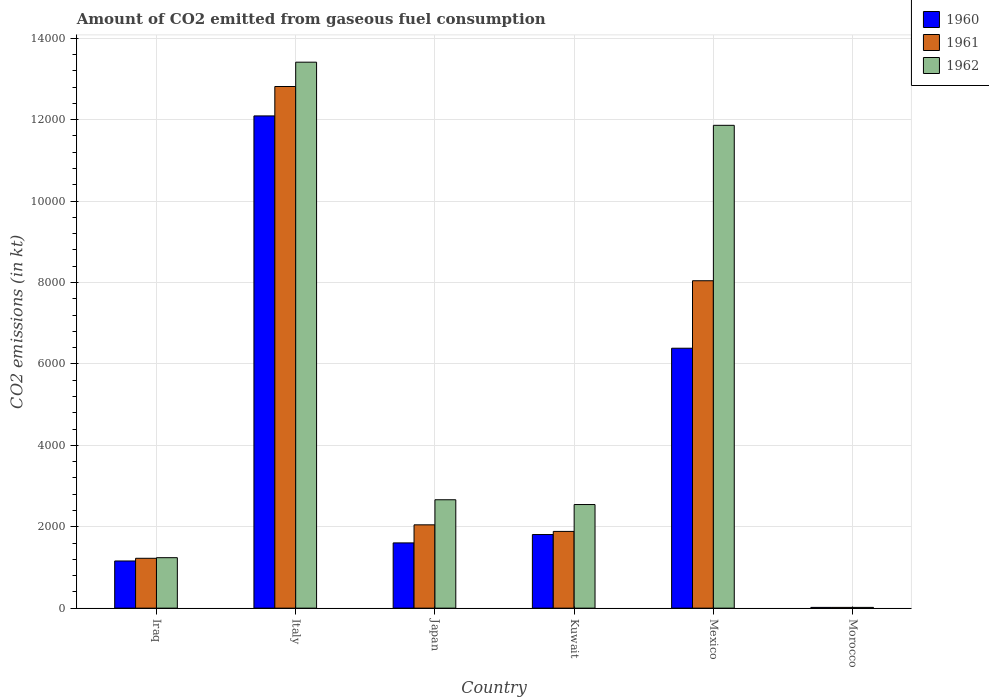How many different coloured bars are there?
Your answer should be very brief. 3. Are the number of bars on each tick of the X-axis equal?
Keep it short and to the point. Yes. How many bars are there on the 1st tick from the left?
Make the answer very short. 3. In how many cases, is the number of bars for a given country not equal to the number of legend labels?
Provide a short and direct response. 0. What is the amount of CO2 emitted in 1962 in Mexico?
Provide a short and direct response. 1.19e+04. Across all countries, what is the maximum amount of CO2 emitted in 1962?
Provide a short and direct response. 1.34e+04. Across all countries, what is the minimum amount of CO2 emitted in 1962?
Offer a terse response. 18.34. In which country was the amount of CO2 emitted in 1961 minimum?
Keep it short and to the point. Morocco. What is the total amount of CO2 emitted in 1962 in the graph?
Offer a very short reply. 3.17e+04. What is the difference between the amount of CO2 emitted in 1960 in Iraq and that in Morocco?
Ensure brevity in your answer.  1140.44. What is the difference between the amount of CO2 emitted in 1962 in Kuwait and the amount of CO2 emitted in 1960 in Morocco?
Provide a short and direct response. 2526.56. What is the average amount of CO2 emitted in 1960 per country?
Your answer should be very brief. 3843.63. What is the difference between the amount of CO2 emitted of/in 1960 and amount of CO2 emitted of/in 1961 in Iraq?
Your answer should be compact. -66.01. In how many countries, is the amount of CO2 emitted in 1961 greater than 7600 kt?
Give a very brief answer. 2. What is the ratio of the amount of CO2 emitted in 1962 in Iraq to that in Italy?
Provide a succinct answer. 0.09. Is the difference between the amount of CO2 emitted in 1960 in Iraq and Japan greater than the difference between the amount of CO2 emitted in 1961 in Iraq and Japan?
Ensure brevity in your answer.  Yes. What is the difference between the highest and the second highest amount of CO2 emitted in 1960?
Your answer should be very brief. -5705.85. What is the difference between the highest and the lowest amount of CO2 emitted in 1960?
Give a very brief answer. 1.21e+04. What does the 2nd bar from the left in Iraq represents?
Your answer should be compact. 1961. Does the graph contain any zero values?
Your answer should be compact. No. Does the graph contain grids?
Offer a terse response. Yes. Where does the legend appear in the graph?
Offer a terse response. Top right. How many legend labels are there?
Offer a very short reply. 3. How are the legend labels stacked?
Provide a short and direct response. Vertical. What is the title of the graph?
Provide a succinct answer. Amount of CO2 emitted from gaseous fuel consumption. What is the label or title of the X-axis?
Provide a short and direct response. Country. What is the label or title of the Y-axis?
Give a very brief answer. CO2 emissions (in kt). What is the CO2 emissions (in kt) in 1960 in Iraq?
Your answer should be very brief. 1158.77. What is the CO2 emissions (in kt) in 1961 in Iraq?
Provide a succinct answer. 1224.78. What is the CO2 emissions (in kt) of 1962 in Iraq?
Keep it short and to the point. 1239.45. What is the CO2 emissions (in kt) of 1960 in Italy?
Give a very brief answer. 1.21e+04. What is the CO2 emissions (in kt) in 1961 in Italy?
Provide a short and direct response. 1.28e+04. What is the CO2 emissions (in kt) of 1962 in Italy?
Offer a very short reply. 1.34e+04. What is the CO2 emissions (in kt) of 1960 in Japan?
Your answer should be very brief. 1602.48. What is the CO2 emissions (in kt) of 1961 in Japan?
Ensure brevity in your answer.  2046.19. What is the CO2 emissions (in kt) in 1962 in Japan?
Your answer should be compact. 2662.24. What is the CO2 emissions (in kt) of 1960 in Kuwait?
Ensure brevity in your answer.  1807.83. What is the CO2 emissions (in kt) in 1961 in Kuwait?
Your answer should be compact. 1884.84. What is the CO2 emissions (in kt) of 1962 in Kuwait?
Provide a short and direct response. 2544.9. What is the CO2 emissions (in kt) of 1960 in Mexico?
Ensure brevity in your answer.  6384.25. What is the CO2 emissions (in kt) of 1961 in Mexico?
Your answer should be very brief. 8041.73. What is the CO2 emissions (in kt) in 1962 in Mexico?
Offer a terse response. 1.19e+04. What is the CO2 emissions (in kt) of 1960 in Morocco?
Offer a very short reply. 18.34. What is the CO2 emissions (in kt) of 1961 in Morocco?
Give a very brief answer. 18.34. What is the CO2 emissions (in kt) in 1962 in Morocco?
Offer a very short reply. 18.34. Across all countries, what is the maximum CO2 emissions (in kt) in 1960?
Your answer should be very brief. 1.21e+04. Across all countries, what is the maximum CO2 emissions (in kt) of 1961?
Make the answer very short. 1.28e+04. Across all countries, what is the maximum CO2 emissions (in kt) in 1962?
Provide a short and direct response. 1.34e+04. Across all countries, what is the minimum CO2 emissions (in kt) in 1960?
Offer a very short reply. 18.34. Across all countries, what is the minimum CO2 emissions (in kt) in 1961?
Make the answer very short. 18.34. Across all countries, what is the minimum CO2 emissions (in kt) of 1962?
Your answer should be compact. 18.34. What is the total CO2 emissions (in kt) in 1960 in the graph?
Ensure brevity in your answer.  2.31e+04. What is the total CO2 emissions (in kt) of 1961 in the graph?
Your response must be concise. 2.60e+04. What is the total CO2 emissions (in kt) of 1962 in the graph?
Keep it short and to the point. 3.17e+04. What is the difference between the CO2 emissions (in kt) in 1960 in Iraq and that in Italy?
Ensure brevity in your answer.  -1.09e+04. What is the difference between the CO2 emissions (in kt) in 1961 in Iraq and that in Italy?
Offer a terse response. -1.16e+04. What is the difference between the CO2 emissions (in kt) in 1962 in Iraq and that in Italy?
Your answer should be compact. -1.22e+04. What is the difference between the CO2 emissions (in kt) of 1960 in Iraq and that in Japan?
Ensure brevity in your answer.  -443.71. What is the difference between the CO2 emissions (in kt) in 1961 in Iraq and that in Japan?
Offer a very short reply. -821.41. What is the difference between the CO2 emissions (in kt) of 1962 in Iraq and that in Japan?
Ensure brevity in your answer.  -1422.8. What is the difference between the CO2 emissions (in kt) in 1960 in Iraq and that in Kuwait?
Offer a very short reply. -649.06. What is the difference between the CO2 emissions (in kt) of 1961 in Iraq and that in Kuwait?
Your response must be concise. -660.06. What is the difference between the CO2 emissions (in kt) of 1962 in Iraq and that in Kuwait?
Give a very brief answer. -1305.45. What is the difference between the CO2 emissions (in kt) in 1960 in Iraq and that in Mexico?
Your answer should be compact. -5225.48. What is the difference between the CO2 emissions (in kt) of 1961 in Iraq and that in Mexico?
Your response must be concise. -6816.95. What is the difference between the CO2 emissions (in kt) of 1962 in Iraq and that in Mexico?
Your answer should be very brief. -1.06e+04. What is the difference between the CO2 emissions (in kt) in 1960 in Iraq and that in Morocco?
Provide a short and direct response. 1140.44. What is the difference between the CO2 emissions (in kt) of 1961 in Iraq and that in Morocco?
Offer a terse response. 1206.44. What is the difference between the CO2 emissions (in kt) in 1962 in Iraq and that in Morocco?
Make the answer very short. 1221.11. What is the difference between the CO2 emissions (in kt) in 1960 in Italy and that in Japan?
Your answer should be compact. 1.05e+04. What is the difference between the CO2 emissions (in kt) of 1961 in Italy and that in Japan?
Offer a very short reply. 1.08e+04. What is the difference between the CO2 emissions (in kt) in 1962 in Italy and that in Japan?
Your response must be concise. 1.07e+04. What is the difference between the CO2 emissions (in kt) of 1960 in Italy and that in Kuwait?
Your response must be concise. 1.03e+04. What is the difference between the CO2 emissions (in kt) in 1961 in Italy and that in Kuwait?
Keep it short and to the point. 1.09e+04. What is the difference between the CO2 emissions (in kt) in 1962 in Italy and that in Kuwait?
Provide a short and direct response. 1.09e+04. What is the difference between the CO2 emissions (in kt) of 1960 in Italy and that in Mexico?
Offer a very short reply. 5705.85. What is the difference between the CO2 emissions (in kt) of 1961 in Italy and that in Mexico?
Offer a very short reply. 4770.77. What is the difference between the CO2 emissions (in kt) in 1962 in Italy and that in Mexico?
Your answer should be compact. 1551.14. What is the difference between the CO2 emissions (in kt) of 1960 in Italy and that in Morocco?
Your response must be concise. 1.21e+04. What is the difference between the CO2 emissions (in kt) in 1961 in Italy and that in Morocco?
Keep it short and to the point. 1.28e+04. What is the difference between the CO2 emissions (in kt) in 1962 in Italy and that in Morocco?
Ensure brevity in your answer.  1.34e+04. What is the difference between the CO2 emissions (in kt) of 1960 in Japan and that in Kuwait?
Your answer should be very brief. -205.35. What is the difference between the CO2 emissions (in kt) of 1961 in Japan and that in Kuwait?
Provide a short and direct response. 161.35. What is the difference between the CO2 emissions (in kt) in 1962 in Japan and that in Kuwait?
Your answer should be compact. 117.34. What is the difference between the CO2 emissions (in kt) in 1960 in Japan and that in Mexico?
Your answer should be compact. -4781.77. What is the difference between the CO2 emissions (in kt) of 1961 in Japan and that in Mexico?
Offer a terse response. -5995.55. What is the difference between the CO2 emissions (in kt) of 1962 in Japan and that in Mexico?
Provide a short and direct response. -9196.84. What is the difference between the CO2 emissions (in kt) of 1960 in Japan and that in Morocco?
Your answer should be compact. 1584.14. What is the difference between the CO2 emissions (in kt) of 1961 in Japan and that in Morocco?
Provide a short and direct response. 2027.85. What is the difference between the CO2 emissions (in kt) in 1962 in Japan and that in Morocco?
Offer a terse response. 2643.91. What is the difference between the CO2 emissions (in kt) of 1960 in Kuwait and that in Mexico?
Provide a succinct answer. -4576.42. What is the difference between the CO2 emissions (in kt) of 1961 in Kuwait and that in Mexico?
Provide a short and direct response. -6156.89. What is the difference between the CO2 emissions (in kt) in 1962 in Kuwait and that in Mexico?
Offer a terse response. -9314.18. What is the difference between the CO2 emissions (in kt) of 1960 in Kuwait and that in Morocco?
Provide a succinct answer. 1789.5. What is the difference between the CO2 emissions (in kt) in 1961 in Kuwait and that in Morocco?
Provide a short and direct response. 1866.5. What is the difference between the CO2 emissions (in kt) in 1962 in Kuwait and that in Morocco?
Provide a short and direct response. 2526.56. What is the difference between the CO2 emissions (in kt) of 1960 in Mexico and that in Morocco?
Provide a succinct answer. 6365.91. What is the difference between the CO2 emissions (in kt) of 1961 in Mexico and that in Morocco?
Keep it short and to the point. 8023.4. What is the difference between the CO2 emissions (in kt) of 1962 in Mexico and that in Morocco?
Make the answer very short. 1.18e+04. What is the difference between the CO2 emissions (in kt) in 1960 in Iraq and the CO2 emissions (in kt) in 1961 in Italy?
Make the answer very short. -1.17e+04. What is the difference between the CO2 emissions (in kt) of 1960 in Iraq and the CO2 emissions (in kt) of 1962 in Italy?
Ensure brevity in your answer.  -1.23e+04. What is the difference between the CO2 emissions (in kt) in 1961 in Iraq and the CO2 emissions (in kt) in 1962 in Italy?
Offer a very short reply. -1.22e+04. What is the difference between the CO2 emissions (in kt) of 1960 in Iraq and the CO2 emissions (in kt) of 1961 in Japan?
Your answer should be compact. -887.41. What is the difference between the CO2 emissions (in kt) of 1960 in Iraq and the CO2 emissions (in kt) of 1962 in Japan?
Give a very brief answer. -1503.47. What is the difference between the CO2 emissions (in kt) in 1961 in Iraq and the CO2 emissions (in kt) in 1962 in Japan?
Provide a short and direct response. -1437.46. What is the difference between the CO2 emissions (in kt) in 1960 in Iraq and the CO2 emissions (in kt) in 1961 in Kuwait?
Your answer should be compact. -726.07. What is the difference between the CO2 emissions (in kt) in 1960 in Iraq and the CO2 emissions (in kt) in 1962 in Kuwait?
Ensure brevity in your answer.  -1386.13. What is the difference between the CO2 emissions (in kt) of 1961 in Iraq and the CO2 emissions (in kt) of 1962 in Kuwait?
Make the answer very short. -1320.12. What is the difference between the CO2 emissions (in kt) of 1960 in Iraq and the CO2 emissions (in kt) of 1961 in Mexico?
Offer a terse response. -6882.96. What is the difference between the CO2 emissions (in kt) of 1960 in Iraq and the CO2 emissions (in kt) of 1962 in Mexico?
Make the answer very short. -1.07e+04. What is the difference between the CO2 emissions (in kt) of 1961 in Iraq and the CO2 emissions (in kt) of 1962 in Mexico?
Provide a succinct answer. -1.06e+04. What is the difference between the CO2 emissions (in kt) of 1960 in Iraq and the CO2 emissions (in kt) of 1961 in Morocco?
Your response must be concise. 1140.44. What is the difference between the CO2 emissions (in kt) of 1960 in Iraq and the CO2 emissions (in kt) of 1962 in Morocco?
Your response must be concise. 1140.44. What is the difference between the CO2 emissions (in kt) of 1961 in Iraq and the CO2 emissions (in kt) of 1962 in Morocco?
Offer a very short reply. 1206.44. What is the difference between the CO2 emissions (in kt) in 1960 in Italy and the CO2 emissions (in kt) in 1961 in Japan?
Keep it short and to the point. 1.00e+04. What is the difference between the CO2 emissions (in kt) in 1960 in Italy and the CO2 emissions (in kt) in 1962 in Japan?
Make the answer very short. 9427.86. What is the difference between the CO2 emissions (in kt) in 1961 in Italy and the CO2 emissions (in kt) in 1962 in Japan?
Give a very brief answer. 1.02e+04. What is the difference between the CO2 emissions (in kt) in 1960 in Italy and the CO2 emissions (in kt) in 1961 in Kuwait?
Your answer should be compact. 1.02e+04. What is the difference between the CO2 emissions (in kt) in 1960 in Italy and the CO2 emissions (in kt) in 1962 in Kuwait?
Provide a short and direct response. 9545.2. What is the difference between the CO2 emissions (in kt) in 1961 in Italy and the CO2 emissions (in kt) in 1962 in Kuwait?
Keep it short and to the point. 1.03e+04. What is the difference between the CO2 emissions (in kt) in 1960 in Italy and the CO2 emissions (in kt) in 1961 in Mexico?
Your answer should be compact. 4048.37. What is the difference between the CO2 emissions (in kt) of 1960 in Italy and the CO2 emissions (in kt) of 1962 in Mexico?
Ensure brevity in your answer.  231.02. What is the difference between the CO2 emissions (in kt) of 1961 in Italy and the CO2 emissions (in kt) of 1962 in Mexico?
Your response must be concise. 953.42. What is the difference between the CO2 emissions (in kt) of 1960 in Italy and the CO2 emissions (in kt) of 1961 in Morocco?
Offer a terse response. 1.21e+04. What is the difference between the CO2 emissions (in kt) in 1960 in Italy and the CO2 emissions (in kt) in 1962 in Morocco?
Offer a very short reply. 1.21e+04. What is the difference between the CO2 emissions (in kt) in 1961 in Italy and the CO2 emissions (in kt) in 1962 in Morocco?
Your answer should be very brief. 1.28e+04. What is the difference between the CO2 emissions (in kt) in 1960 in Japan and the CO2 emissions (in kt) in 1961 in Kuwait?
Your response must be concise. -282.36. What is the difference between the CO2 emissions (in kt) in 1960 in Japan and the CO2 emissions (in kt) in 1962 in Kuwait?
Your answer should be very brief. -942.42. What is the difference between the CO2 emissions (in kt) of 1961 in Japan and the CO2 emissions (in kt) of 1962 in Kuwait?
Provide a short and direct response. -498.71. What is the difference between the CO2 emissions (in kt) in 1960 in Japan and the CO2 emissions (in kt) in 1961 in Mexico?
Give a very brief answer. -6439.25. What is the difference between the CO2 emissions (in kt) of 1960 in Japan and the CO2 emissions (in kt) of 1962 in Mexico?
Offer a very short reply. -1.03e+04. What is the difference between the CO2 emissions (in kt) in 1961 in Japan and the CO2 emissions (in kt) in 1962 in Mexico?
Keep it short and to the point. -9812.89. What is the difference between the CO2 emissions (in kt) in 1960 in Japan and the CO2 emissions (in kt) in 1961 in Morocco?
Provide a short and direct response. 1584.14. What is the difference between the CO2 emissions (in kt) in 1960 in Japan and the CO2 emissions (in kt) in 1962 in Morocco?
Your answer should be compact. 1584.14. What is the difference between the CO2 emissions (in kt) of 1961 in Japan and the CO2 emissions (in kt) of 1962 in Morocco?
Give a very brief answer. 2027.85. What is the difference between the CO2 emissions (in kt) in 1960 in Kuwait and the CO2 emissions (in kt) in 1961 in Mexico?
Offer a terse response. -6233.9. What is the difference between the CO2 emissions (in kt) in 1960 in Kuwait and the CO2 emissions (in kt) in 1962 in Mexico?
Make the answer very short. -1.01e+04. What is the difference between the CO2 emissions (in kt) in 1961 in Kuwait and the CO2 emissions (in kt) in 1962 in Mexico?
Your answer should be compact. -9974.24. What is the difference between the CO2 emissions (in kt) of 1960 in Kuwait and the CO2 emissions (in kt) of 1961 in Morocco?
Keep it short and to the point. 1789.5. What is the difference between the CO2 emissions (in kt) in 1960 in Kuwait and the CO2 emissions (in kt) in 1962 in Morocco?
Offer a very short reply. 1789.5. What is the difference between the CO2 emissions (in kt) in 1961 in Kuwait and the CO2 emissions (in kt) in 1962 in Morocco?
Offer a terse response. 1866.5. What is the difference between the CO2 emissions (in kt) in 1960 in Mexico and the CO2 emissions (in kt) in 1961 in Morocco?
Provide a succinct answer. 6365.91. What is the difference between the CO2 emissions (in kt) of 1960 in Mexico and the CO2 emissions (in kt) of 1962 in Morocco?
Your answer should be compact. 6365.91. What is the difference between the CO2 emissions (in kt) in 1961 in Mexico and the CO2 emissions (in kt) in 1962 in Morocco?
Provide a succinct answer. 8023.4. What is the average CO2 emissions (in kt) in 1960 per country?
Make the answer very short. 3843.63. What is the average CO2 emissions (in kt) in 1961 per country?
Your answer should be very brief. 4338.06. What is the average CO2 emissions (in kt) of 1962 per country?
Give a very brief answer. 5289.04. What is the difference between the CO2 emissions (in kt) in 1960 and CO2 emissions (in kt) in 1961 in Iraq?
Offer a very short reply. -66.01. What is the difference between the CO2 emissions (in kt) of 1960 and CO2 emissions (in kt) of 1962 in Iraq?
Your answer should be compact. -80.67. What is the difference between the CO2 emissions (in kt) in 1961 and CO2 emissions (in kt) in 1962 in Iraq?
Your answer should be compact. -14.67. What is the difference between the CO2 emissions (in kt) in 1960 and CO2 emissions (in kt) in 1961 in Italy?
Your response must be concise. -722.4. What is the difference between the CO2 emissions (in kt) in 1960 and CO2 emissions (in kt) in 1962 in Italy?
Make the answer very short. -1320.12. What is the difference between the CO2 emissions (in kt) of 1961 and CO2 emissions (in kt) of 1962 in Italy?
Provide a succinct answer. -597.72. What is the difference between the CO2 emissions (in kt) of 1960 and CO2 emissions (in kt) of 1961 in Japan?
Offer a very short reply. -443.71. What is the difference between the CO2 emissions (in kt) in 1960 and CO2 emissions (in kt) in 1962 in Japan?
Provide a short and direct response. -1059.76. What is the difference between the CO2 emissions (in kt) of 1961 and CO2 emissions (in kt) of 1962 in Japan?
Ensure brevity in your answer.  -616.06. What is the difference between the CO2 emissions (in kt) of 1960 and CO2 emissions (in kt) of 1961 in Kuwait?
Your answer should be very brief. -77.01. What is the difference between the CO2 emissions (in kt) in 1960 and CO2 emissions (in kt) in 1962 in Kuwait?
Provide a succinct answer. -737.07. What is the difference between the CO2 emissions (in kt) in 1961 and CO2 emissions (in kt) in 1962 in Kuwait?
Your response must be concise. -660.06. What is the difference between the CO2 emissions (in kt) of 1960 and CO2 emissions (in kt) of 1961 in Mexico?
Keep it short and to the point. -1657.48. What is the difference between the CO2 emissions (in kt) in 1960 and CO2 emissions (in kt) in 1962 in Mexico?
Give a very brief answer. -5474.83. What is the difference between the CO2 emissions (in kt) in 1961 and CO2 emissions (in kt) in 1962 in Mexico?
Your response must be concise. -3817.35. What is the difference between the CO2 emissions (in kt) in 1960 and CO2 emissions (in kt) in 1961 in Morocco?
Give a very brief answer. 0. What is the difference between the CO2 emissions (in kt) of 1961 and CO2 emissions (in kt) of 1962 in Morocco?
Provide a succinct answer. 0. What is the ratio of the CO2 emissions (in kt) of 1960 in Iraq to that in Italy?
Ensure brevity in your answer.  0.1. What is the ratio of the CO2 emissions (in kt) of 1961 in Iraq to that in Italy?
Ensure brevity in your answer.  0.1. What is the ratio of the CO2 emissions (in kt) of 1962 in Iraq to that in Italy?
Your answer should be compact. 0.09. What is the ratio of the CO2 emissions (in kt) of 1960 in Iraq to that in Japan?
Offer a terse response. 0.72. What is the ratio of the CO2 emissions (in kt) in 1961 in Iraq to that in Japan?
Provide a succinct answer. 0.6. What is the ratio of the CO2 emissions (in kt) in 1962 in Iraq to that in Japan?
Offer a terse response. 0.47. What is the ratio of the CO2 emissions (in kt) of 1960 in Iraq to that in Kuwait?
Offer a terse response. 0.64. What is the ratio of the CO2 emissions (in kt) in 1961 in Iraq to that in Kuwait?
Provide a succinct answer. 0.65. What is the ratio of the CO2 emissions (in kt) of 1962 in Iraq to that in Kuwait?
Provide a succinct answer. 0.49. What is the ratio of the CO2 emissions (in kt) in 1960 in Iraq to that in Mexico?
Your response must be concise. 0.18. What is the ratio of the CO2 emissions (in kt) in 1961 in Iraq to that in Mexico?
Offer a very short reply. 0.15. What is the ratio of the CO2 emissions (in kt) in 1962 in Iraq to that in Mexico?
Ensure brevity in your answer.  0.1. What is the ratio of the CO2 emissions (in kt) of 1960 in Iraq to that in Morocco?
Your answer should be compact. 63.2. What is the ratio of the CO2 emissions (in kt) in 1961 in Iraq to that in Morocco?
Your answer should be compact. 66.8. What is the ratio of the CO2 emissions (in kt) of 1962 in Iraq to that in Morocco?
Your answer should be very brief. 67.6. What is the ratio of the CO2 emissions (in kt) in 1960 in Italy to that in Japan?
Provide a succinct answer. 7.54. What is the ratio of the CO2 emissions (in kt) in 1961 in Italy to that in Japan?
Keep it short and to the point. 6.26. What is the ratio of the CO2 emissions (in kt) in 1962 in Italy to that in Japan?
Provide a succinct answer. 5.04. What is the ratio of the CO2 emissions (in kt) in 1960 in Italy to that in Kuwait?
Keep it short and to the point. 6.69. What is the ratio of the CO2 emissions (in kt) in 1961 in Italy to that in Kuwait?
Offer a very short reply. 6.8. What is the ratio of the CO2 emissions (in kt) in 1962 in Italy to that in Kuwait?
Ensure brevity in your answer.  5.27. What is the ratio of the CO2 emissions (in kt) of 1960 in Italy to that in Mexico?
Your answer should be compact. 1.89. What is the ratio of the CO2 emissions (in kt) of 1961 in Italy to that in Mexico?
Your answer should be very brief. 1.59. What is the ratio of the CO2 emissions (in kt) of 1962 in Italy to that in Mexico?
Ensure brevity in your answer.  1.13. What is the ratio of the CO2 emissions (in kt) in 1960 in Italy to that in Morocco?
Provide a succinct answer. 659.4. What is the ratio of the CO2 emissions (in kt) in 1961 in Italy to that in Morocco?
Offer a very short reply. 698.8. What is the ratio of the CO2 emissions (in kt) of 1962 in Italy to that in Morocco?
Keep it short and to the point. 731.4. What is the ratio of the CO2 emissions (in kt) of 1960 in Japan to that in Kuwait?
Provide a succinct answer. 0.89. What is the ratio of the CO2 emissions (in kt) in 1961 in Japan to that in Kuwait?
Provide a short and direct response. 1.09. What is the ratio of the CO2 emissions (in kt) of 1962 in Japan to that in Kuwait?
Ensure brevity in your answer.  1.05. What is the ratio of the CO2 emissions (in kt) of 1960 in Japan to that in Mexico?
Offer a very short reply. 0.25. What is the ratio of the CO2 emissions (in kt) of 1961 in Japan to that in Mexico?
Make the answer very short. 0.25. What is the ratio of the CO2 emissions (in kt) in 1962 in Japan to that in Mexico?
Your answer should be very brief. 0.22. What is the ratio of the CO2 emissions (in kt) of 1960 in Japan to that in Morocco?
Ensure brevity in your answer.  87.4. What is the ratio of the CO2 emissions (in kt) of 1961 in Japan to that in Morocco?
Your response must be concise. 111.6. What is the ratio of the CO2 emissions (in kt) in 1962 in Japan to that in Morocco?
Give a very brief answer. 145.2. What is the ratio of the CO2 emissions (in kt) of 1960 in Kuwait to that in Mexico?
Your answer should be compact. 0.28. What is the ratio of the CO2 emissions (in kt) of 1961 in Kuwait to that in Mexico?
Give a very brief answer. 0.23. What is the ratio of the CO2 emissions (in kt) of 1962 in Kuwait to that in Mexico?
Your response must be concise. 0.21. What is the ratio of the CO2 emissions (in kt) of 1960 in Kuwait to that in Morocco?
Provide a succinct answer. 98.6. What is the ratio of the CO2 emissions (in kt) of 1961 in Kuwait to that in Morocco?
Give a very brief answer. 102.8. What is the ratio of the CO2 emissions (in kt) of 1962 in Kuwait to that in Morocco?
Offer a very short reply. 138.8. What is the ratio of the CO2 emissions (in kt) in 1960 in Mexico to that in Morocco?
Your answer should be compact. 348.2. What is the ratio of the CO2 emissions (in kt) of 1961 in Mexico to that in Morocco?
Offer a terse response. 438.6. What is the ratio of the CO2 emissions (in kt) of 1962 in Mexico to that in Morocco?
Provide a succinct answer. 646.8. What is the difference between the highest and the second highest CO2 emissions (in kt) of 1960?
Your response must be concise. 5705.85. What is the difference between the highest and the second highest CO2 emissions (in kt) of 1961?
Give a very brief answer. 4770.77. What is the difference between the highest and the second highest CO2 emissions (in kt) in 1962?
Your answer should be compact. 1551.14. What is the difference between the highest and the lowest CO2 emissions (in kt) of 1960?
Keep it short and to the point. 1.21e+04. What is the difference between the highest and the lowest CO2 emissions (in kt) of 1961?
Provide a succinct answer. 1.28e+04. What is the difference between the highest and the lowest CO2 emissions (in kt) of 1962?
Make the answer very short. 1.34e+04. 